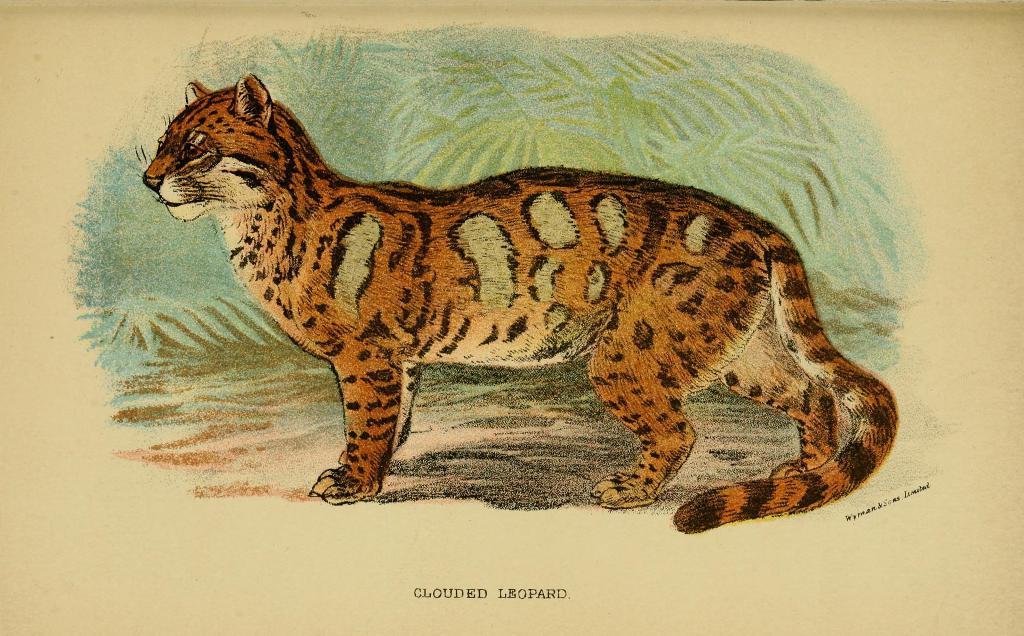In one or two sentences, can you explain what this image depicts? In this picture I can see an animal in the middle, it is a painting. At the bottom there is the text. 